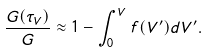<formula> <loc_0><loc_0><loc_500><loc_500>\frac { G ( \tau _ { V } ) } { G } \approx 1 - \int _ { 0 } ^ { V } f ( V ^ { \prime } ) d V ^ { \prime } .</formula> 